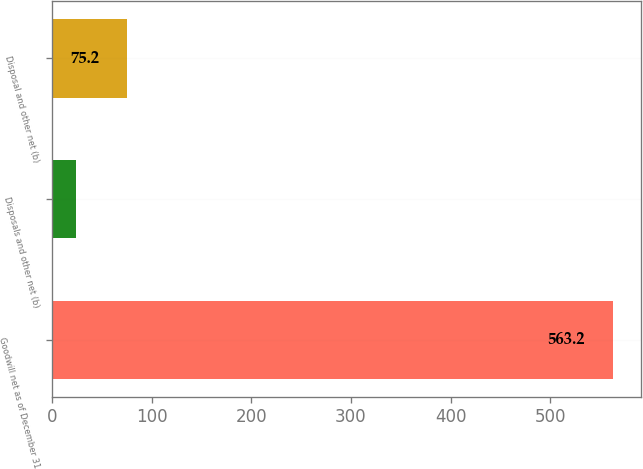<chart> <loc_0><loc_0><loc_500><loc_500><bar_chart><fcel>Goodwill net as of December 31<fcel>Disposals and other net (b)<fcel>Disposal and other net (b)<nl><fcel>563.2<fcel>24<fcel>75.2<nl></chart> 